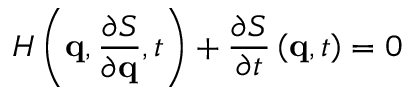Convert formula to latex. <formula><loc_0><loc_0><loc_500><loc_500>H \left ( q , { \frac { \partial S } { \partial q } } , t \right ) + { \frac { \partial S } { \partial t } } \left ( q , t \right ) = 0</formula> 